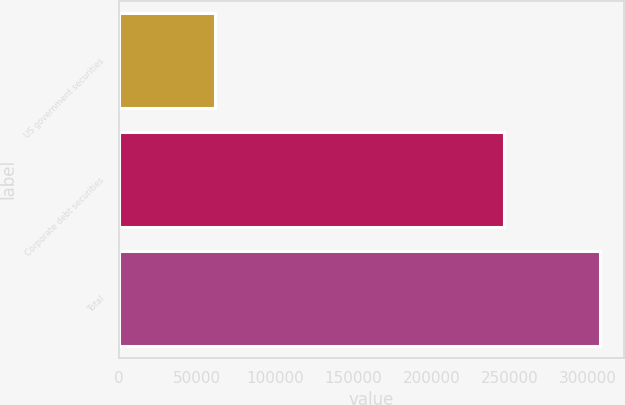Convert chart. <chart><loc_0><loc_0><loc_500><loc_500><bar_chart><fcel>US government securities<fcel>Corporate debt securities<fcel>Total<nl><fcel>61596<fcel>246094<fcel>307690<nl></chart> 